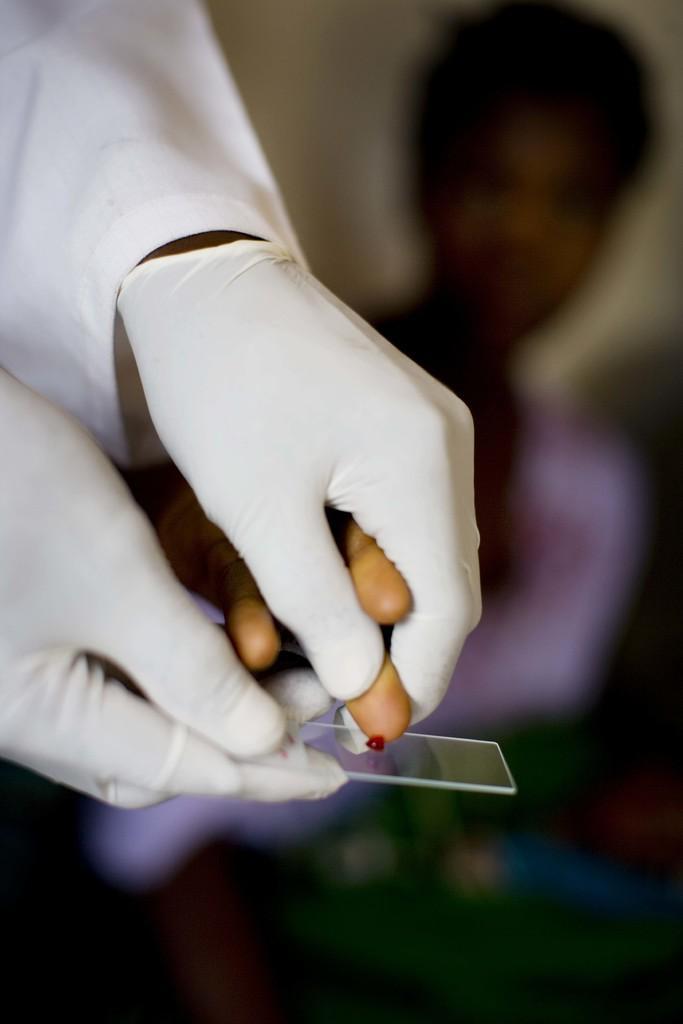Please provide a concise description of this image. This picture describe about the lab technician who is wearing a white gloves in the hand and taking a blood sample on the glass holding a small boy hand. Behind there is a blur background. 